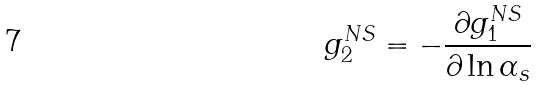<formula> <loc_0><loc_0><loc_500><loc_500>g _ { 2 } ^ { N S } = - \frac { \partial g _ { 1 } ^ { N S } } { \partial \ln \alpha _ { s } }</formula> 